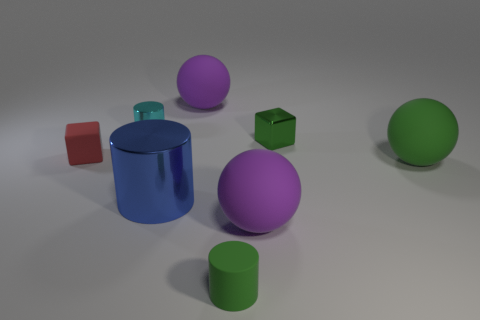Are the purple thing that is to the right of the small green cylinder and the purple thing that is on the left side of the small matte cylinder made of the same material?
Your answer should be very brief. Yes. There is a block to the left of the blue cylinder; is its size the same as the big shiny cylinder?
Your answer should be very brief. No. Does the matte cube have the same color as the shiny cylinder that is in front of the green metal cube?
Your response must be concise. No. What shape is the large thing that is the same color as the tiny metallic cube?
Provide a short and direct response. Sphere. What shape is the big blue shiny thing?
Your response must be concise. Cylinder. Does the rubber cylinder have the same color as the tiny rubber block?
Provide a short and direct response. No. What number of objects are either things behind the big blue cylinder or large blue things?
Provide a short and direct response. 6. What is the size of the green sphere that is made of the same material as the red cube?
Provide a succinct answer. Large. Are there more blue cylinders that are behind the red matte block than small matte balls?
Provide a short and direct response. No. Do the blue object and the small green object on the right side of the small green rubber cylinder have the same shape?
Give a very brief answer. No. 